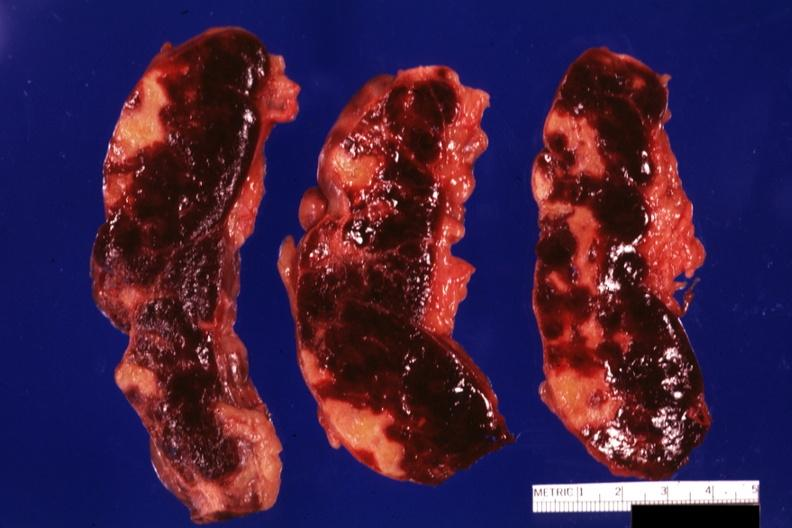s hematologic present?
Answer the question using a single word or phrase. Yes 